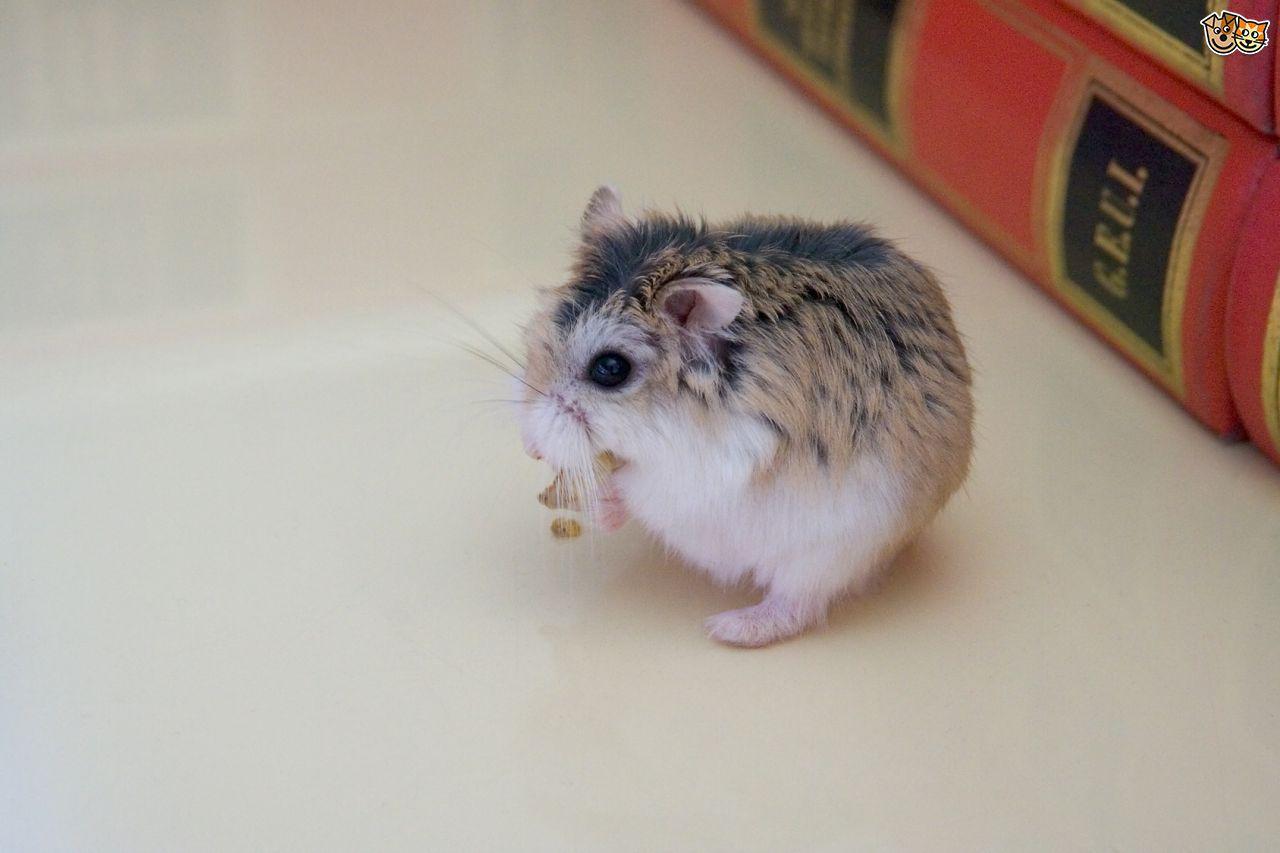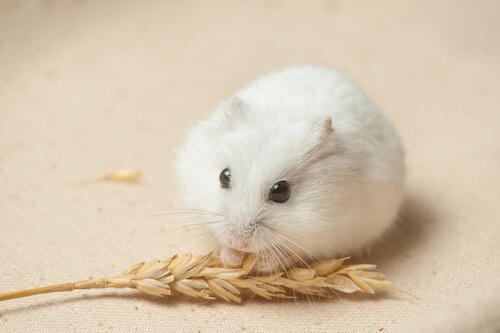The first image is the image on the left, the second image is the image on the right. Given the left and right images, does the statement "The right image contains exactly two rodents." hold true? Answer yes or no. No. The first image is the image on the left, the second image is the image on the right. Evaluate the accuracy of this statement regarding the images: "At least one image shows a small pet rodent posed with a larger pet animal on a white background.". Is it true? Answer yes or no. No. 